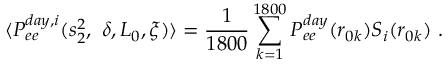Convert formula to latex. <formula><loc_0><loc_0><loc_500><loc_500>\langle P _ { e e } ^ { d a y , i } ( s _ { 2 } ^ { 2 } , \delta , L _ { 0 } , \xi ) \rangle = \frac { 1 } { 1 8 0 0 } \sum _ { k = 1 } ^ { 1 8 0 0 } P _ { e e } ^ { d a y } ( r _ { 0 k } ) S _ { i } ( r _ { 0 k } ) .</formula> 